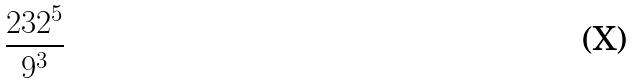<formula> <loc_0><loc_0><loc_500><loc_500>\frac { 2 3 2 ^ { 5 } } { 9 ^ { 3 } }</formula> 